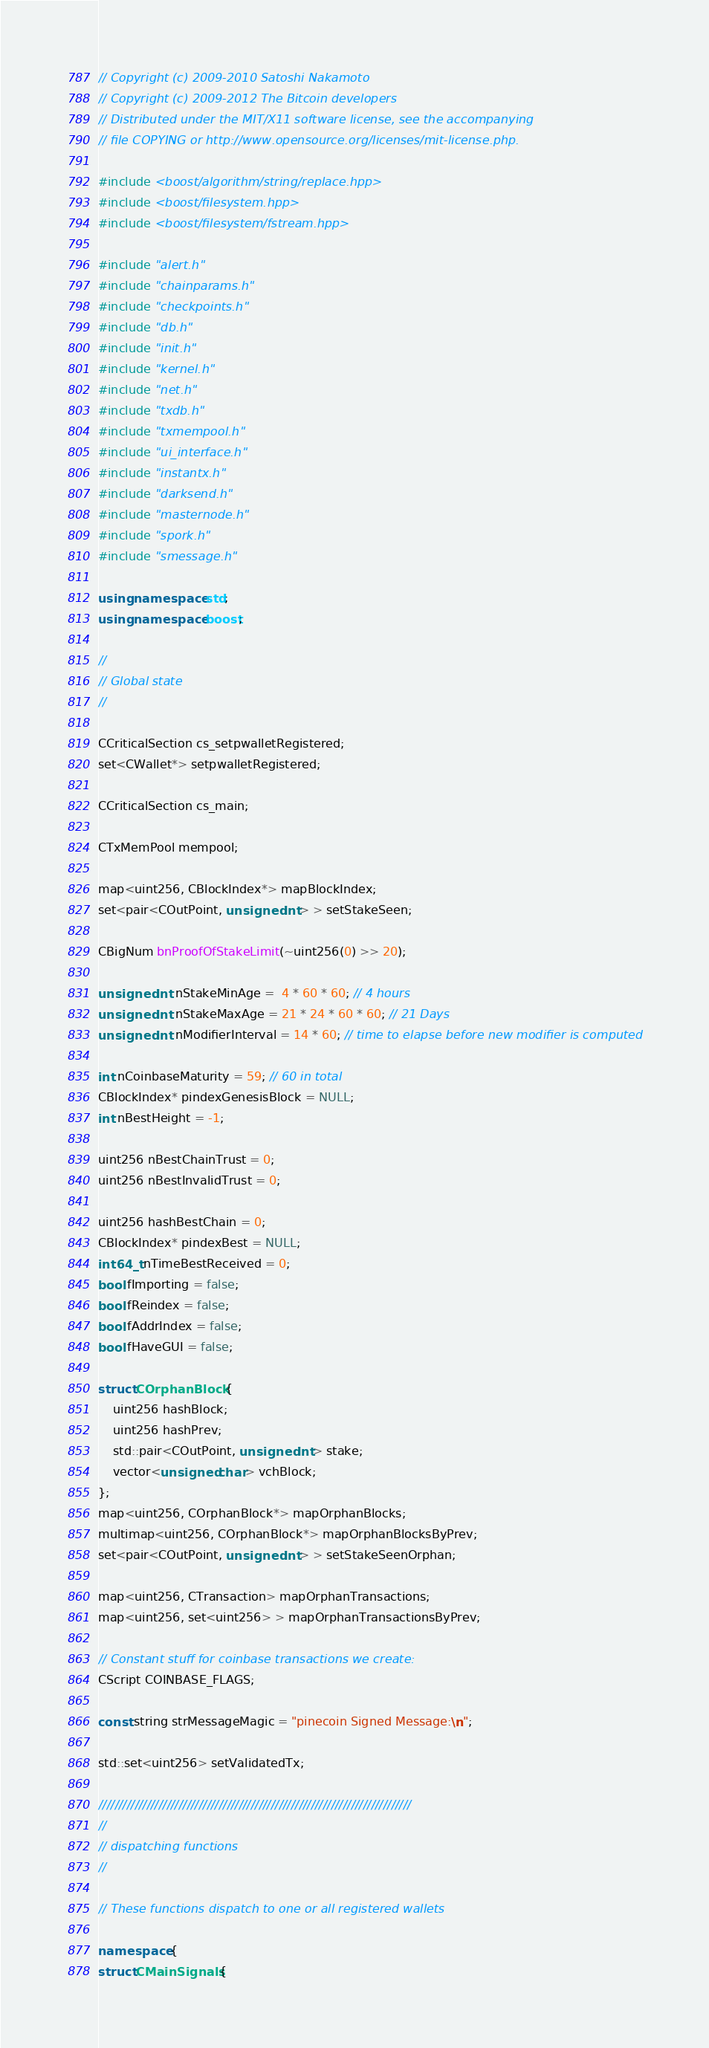<code> <loc_0><loc_0><loc_500><loc_500><_C++_>// Copyright (c) 2009-2010 Satoshi Nakamoto
// Copyright (c) 2009-2012 The Bitcoin developers
// Distributed under the MIT/X11 software license, see the accompanying
// file COPYING or http://www.opensource.org/licenses/mit-license.php.

#include <boost/algorithm/string/replace.hpp>
#include <boost/filesystem.hpp>
#include <boost/filesystem/fstream.hpp>

#include "alert.h"
#include "chainparams.h"
#include "checkpoints.h"
#include "db.h"
#include "init.h"
#include "kernel.h"
#include "net.h"
#include "txdb.h"
#include "txmempool.h"
#include "ui_interface.h"
#include "instantx.h"
#include "darksend.h"
#include "masternode.h"
#include "spork.h"
#include "smessage.h"

using namespace std;
using namespace boost;

//
// Global state
//

CCriticalSection cs_setpwalletRegistered;
set<CWallet*> setpwalletRegistered;

CCriticalSection cs_main;

CTxMemPool mempool;

map<uint256, CBlockIndex*> mapBlockIndex;
set<pair<COutPoint, unsigned int> > setStakeSeen;

CBigNum bnProofOfStakeLimit(~uint256(0) >> 20);

unsigned int nStakeMinAge =  4 * 60 * 60; // 4 hours
unsigned int nStakeMaxAge = 21 * 24 * 60 * 60; // 21 Days
unsigned int nModifierInterval = 14 * 60; // time to elapse before new modifier is computed

int nCoinbaseMaturity = 59; // 60 in total
CBlockIndex* pindexGenesisBlock = NULL;
int nBestHeight = -1;

uint256 nBestChainTrust = 0;
uint256 nBestInvalidTrust = 0;

uint256 hashBestChain = 0;
CBlockIndex* pindexBest = NULL;
int64_t nTimeBestReceived = 0;
bool fImporting = false;
bool fReindex = false;
bool fAddrIndex = false;
bool fHaveGUI = false;

struct COrphanBlock {
    uint256 hashBlock;
    uint256 hashPrev;
    std::pair<COutPoint, unsigned int> stake;
    vector<unsigned char> vchBlock;
};
map<uint256, COrphanBlock*> mapOrphanBlocks;
multimap<uint256, COrphanBlock*> mapOrphanBlocksByPrev;
set<pair<COutPoint, unsigned int> > setStakeSeenOrphan;

map<uint256, CTransaction> mapOrphanTransactions;
map<uint256, set<uint256> > mapOrphanTransactionsByPrev;

// Constant stuff for coinbase transactions we create:
CScript COINBASE_FLAGS;

const string strMessageMagic = "pinecoin Signed Message:\n";

std::set<uint256> setValidatedTx;

//////////////////////////////////////////////////////////////////////////////
//
// dispatching functions
//

// These functions dispatch to one or all registered wallets

namespace {
struct CMainSignals {</code> 